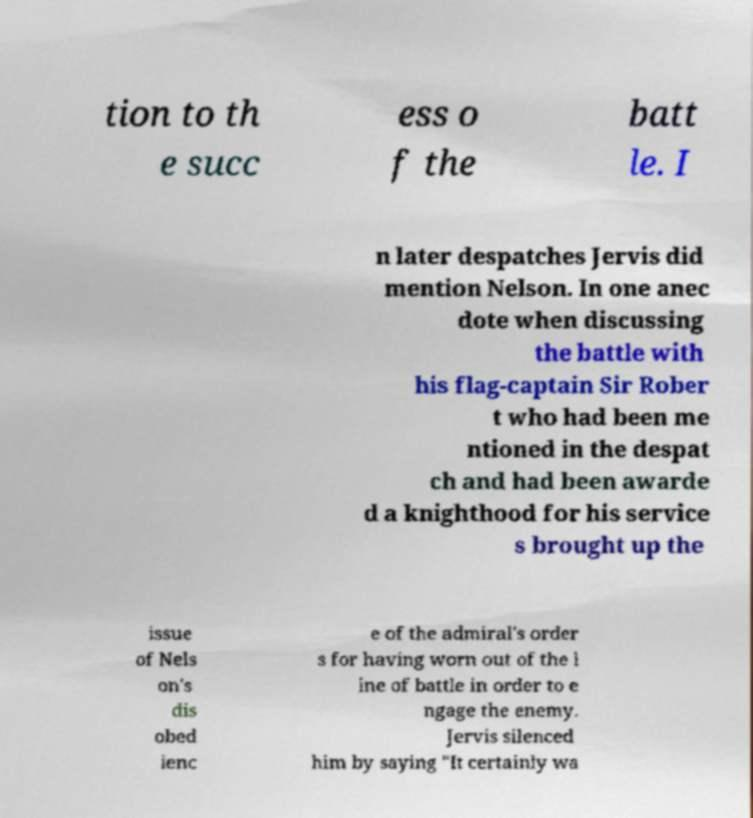Can you accurately transcribe the text from the provided image for me? tion to th e succ ess o f the batt le. I n later despatches Jervis did mention Nelson. In one anec dote when discussing the battle with his flag-captain Sir Rober t who had been me ntioned in the despat ch and had been awarde d a knighthood for his service s brought up the issue of Nels on's dis obed ienc e of the admiral's order s for having worn out of the l ine of battle in order to e ngage the enemy. Jervis silenced him by saying "It certainly wa 